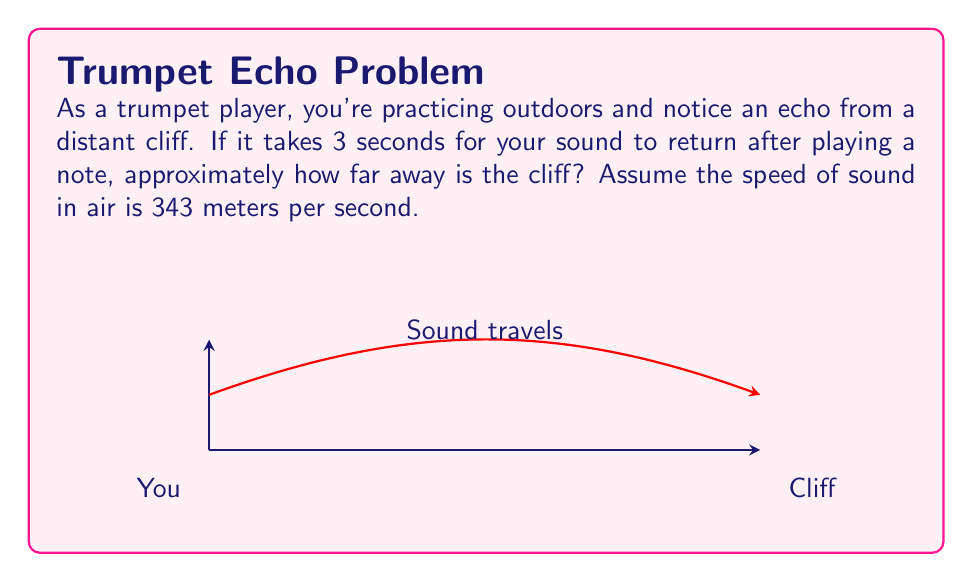Solve this math problem. Let's break this down step-by-step:

1) First, we need to understand that the sound travels to the cliff and back. This means the total distance is twice the distance to the cliff.

2) We're given that the total time for the sound to travel is 3 seconds.

3) The formula for distance is:
   $$\text{Distance} = \text{Speed} \times \text{Time}$$

4) We know the speed of sound is 343 m/s, and the total time is 3 s. Let's call the distance to the cliff $x$. Then:
   $$2x = 343 \text{ m/s} \times 3 \text{ s}$$

5) Simplify the right side:
   $$2x = 1029 \text{ m}$$

6) Solve for $x$:
   $$x = \frac{1029 \text{ m}}{2} = 514.5 \text{ m}$$

7) Round to a reasonable estimate:
   $$x \approx 515 \text{ m}$$

Therefore, the cliff is approximately 515 meters away.
Answer: 515 meters 